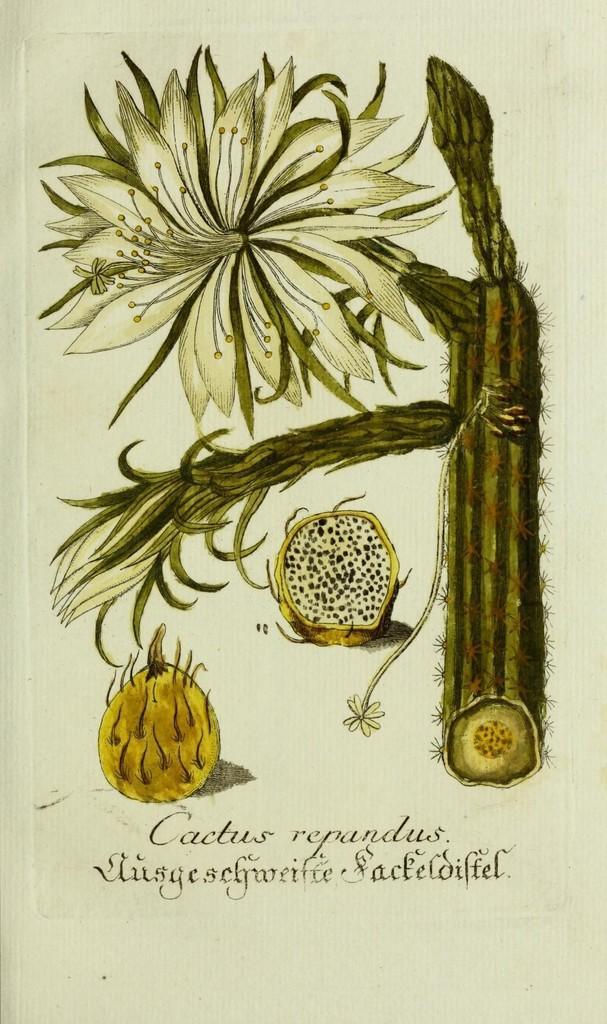Can you describe this image briefly? In this picture we can see a poster, in the poster we can find some text and printed pictures. 